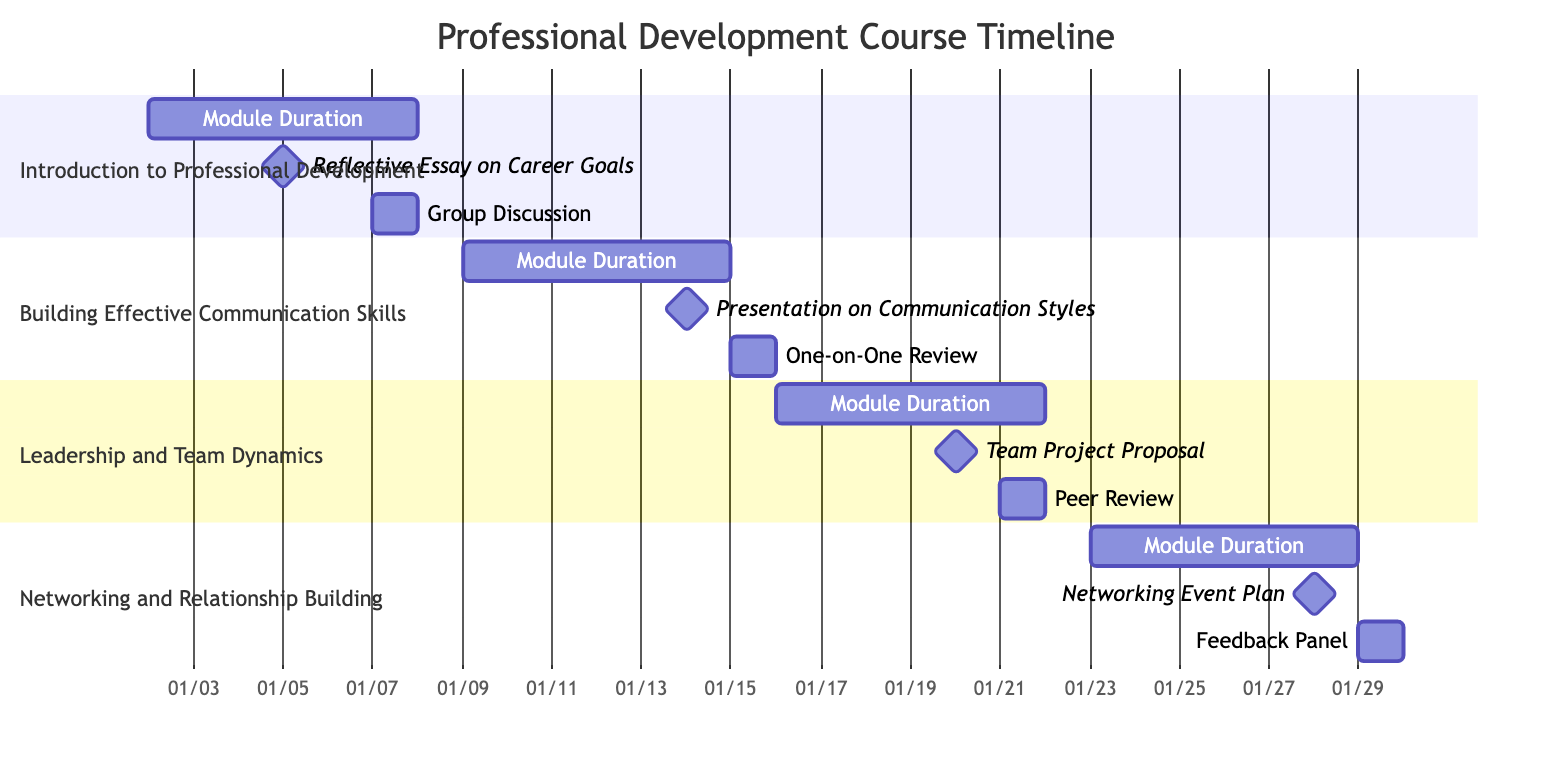What is the first module in the course? The diagram lists the modules in order of progression, and the first module is labeled "Introduction to Professional Development."
Answer: Introduction to Professional Development How long does the module "Building Effective Communication Skills" last? The start date for "Building Effective Communication Skills" is January 9, 2024, and the end date is January 15, 2024. Counting these dates gives a duration of 7 days.
Answer: 7 days What assignment is due on January 5, 2024? In the "Introduction to Professional Development" section, the assignment due on January 5, 2024, is the "Reflective Essay on Career Goals."
Answer: Reflective Essay on Career Goals How many feedback sessions are scheduled after the module "Networking and Relationship Building"? The final module has one feedback session scheduled on January 29, 2024. Since it is the last module, there are no more sessions after this date.
Answer: 0 Which feedback session is associated with the assignment "Team Project Proposal"? In the "Leadership and Team Dynamics" section, the feedback session is labeled "Peer Review," which takes place on January 21, 2024, and it is the feedback session associated with the "Team Project Proposal."
Answer: Peer Review What is the format of the feedback session that occurs on January 29, 2024? The feedback session on January 29, 2024, in the "Networking and Relationship Building" section is labeled as a "Feedback Panel."
Answer: Feedback Panel What module overlaps with the feedback session for the assignment due on January 28, 2024? The assignment "Networking Event Plan," due on January 28, 2024, is part of the "Networking and Relationship Building" module, which comes after the "Leadership and Team Dynamics" module and overlaps until the final feedback session.
Answer: Networking and Relationship Building How many total assignments are there in the course? Counting the assignments from each module: 1 from "Introduction to Professional Development," 1 from "Building Effective Communication Skills," 1 from "Leadership and Team Dynamics," and 1 from "Networking and Relationship Building" results in a total of 4 assignments.
Answer: 4 